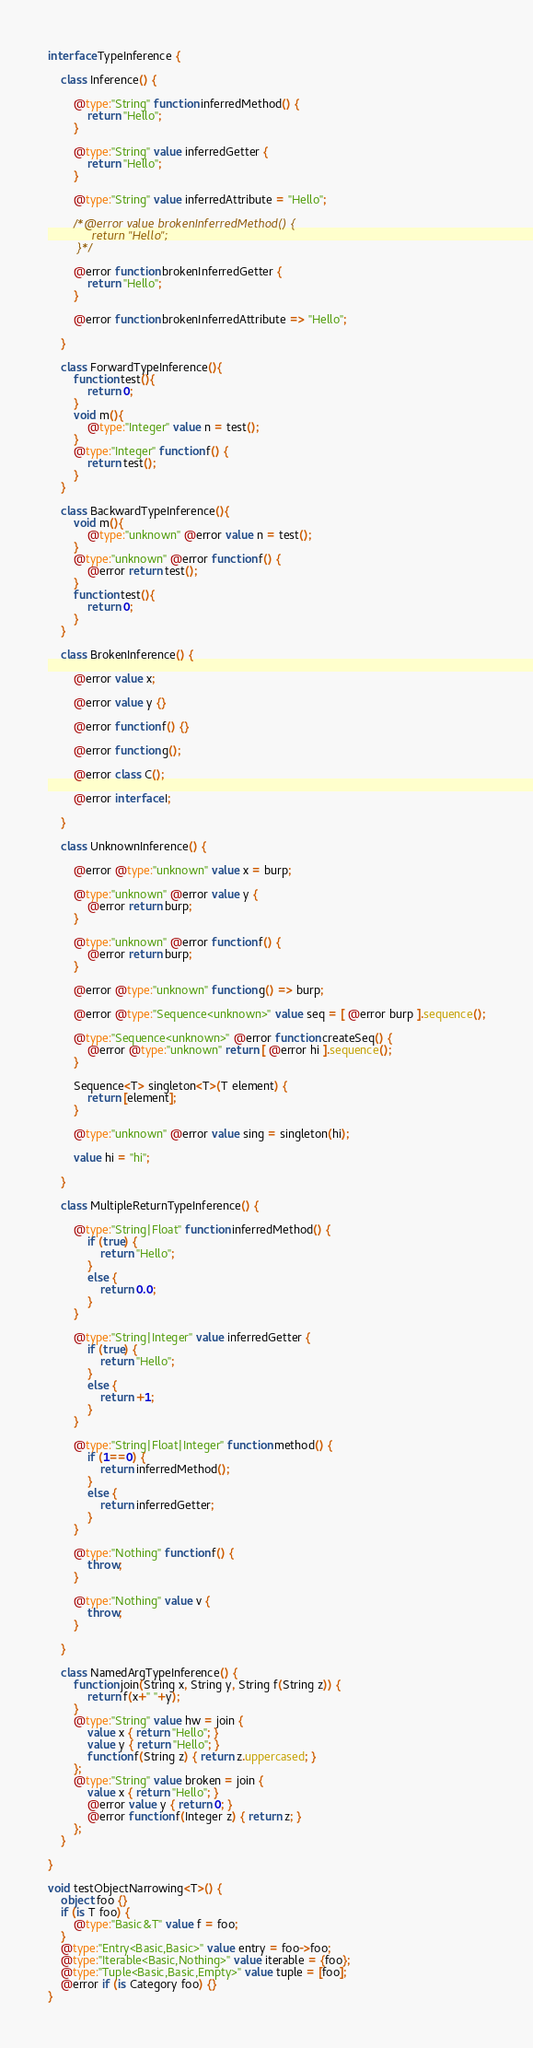Convert code to text. <code><loc_0><loc_0><loc_500><loc_500><_Ceylon_>interface TypeInference {
    
    class Inference() {
    
        @type:"String" function inferredMethod() {
            return "Hello";
        }
        
        @type:"String" value inferredGetter {
            return "Hello";
        }
        
        @type:"String" value inferredAttribute = "Hello";
        
        /*@error value brokenInferredMethod() {
            return "Hello";
        }*/
        
        @error function brokenInferredGetter {
            return "Hello";
        }
        
        @error function brokenInferredAttribute => "Hello";
        
    }
    
    class ForwardTypeInference(){
        function test(){
            return 0;    
        }
        void m(){
            @type:"Integer" value n = test();
        }
        @type:"Integer" function f() {
            return test();
        }
    }
    
    class BackwardTypeInference(){
        void m(){
            @type:"unknown" @error value n = test();
        }
        @type:"unknown" @error function f() {
            @error return test();
        }
        function test(){
            return 0;    
        }
    }
    
    class BrokenInference() {
        
        @error value x;
        
        @error value y {}
        
        @error function f() {}
        
        @error function g();
        
        @error class C();
        
        @error interface I;
        
    }

    class UnknownInference() {
        
        @error @type:"unknown" value x = burp;
        
        @type:"unknown" @error value y {
            @error return burp;
        }
        
        @type:"unknown" @error function f() {
            @error return burp;
        }
        
        @error @type:"unknown" function g() => burp;
        
        @error @type:"Sequence<unknown>" value seq = [ @error burp ].sequence();
        
        @type:"Sequence<unknown>" @error function createSeq() {
            @error @type:"unknown" return [ @error hi ].sequence();
        }
        
        Sequence<T> singleton<T>(T element) {
            return [element];
        }
        
        @type:"unknown" @error value sing = singleton(hi);
        
        value hi = "hi";
        
    }
    
    class MultipleReturnTypeInference() {
        
        @type:"String|Float" function inferredMethod() {
            if (true) {
                return "Hello";
            }
            else {
                return 0.0;
            }
        }
        
        @type:"String|Integer" value inferredGetter {
            if (true) {
                return "Hello";
            }
            else {
                return +1;
            }
        }
        
        @type:"String|Float|Integer" function method() {
            if (1==0) {
                return inferredMethod();
            }
            else {
                return inferredGetter;
            }
        }
        
        @type:"Nothing" function f() {
            throw;
        }
        
        @type:"Nothing" value v {
            throw;
        }
        
    }
    
    class NamedArgTypeInference() {
        function join(String x, String y, String f(String z)) {
            return f(x+" "+y);
        }
        @type:"String" value hw = join {
            value x { return "Hello"; }
            value y { return "Hello"; }
            function f(String z) { return z.uppercased; }
        };
        @type:"String" value broken = join {
            value x { return "Hello"; }
            @error value y { return 0; }
            @error function f(Integer z) { return z; }
        };
    }

}

void testObjectNarrowing<T>() {
    object foo {}
    if (is T foo) {
        @type:"Basic&T" value f = foo;
    }
    @type:"Entry<Basic,Basic>" value entry = foo->foo;
    @type:"Iterable<Basic,Nothing>" value iterable = {foo};
    @type:"Tuple<Basic,Basic,Empty>" value tuple = [foo];
    @error if (is Category foo) {}
}</code> 